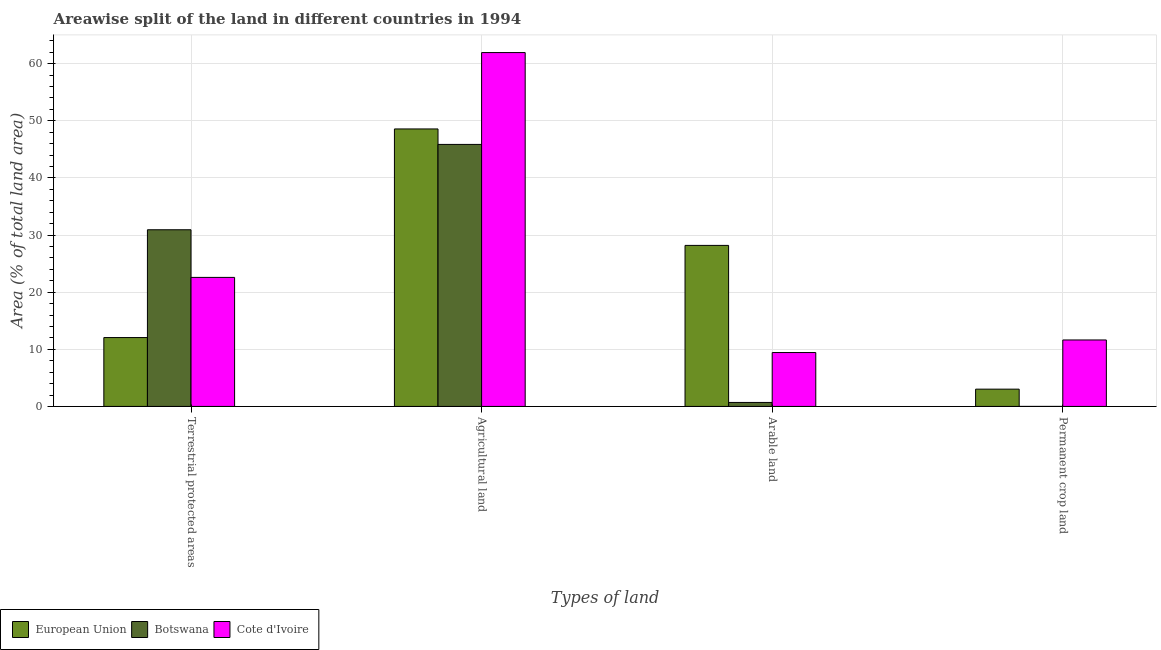How many different coloured bars are there?
Your answer should be very brief. 3. How many groups of bars are there?
Keep it short and to the point. 4. Are the number of bars on each tick of the X-axis equal?
Give a very brief answer. Yes. How many bars are there on the 1st tick from the left?
Your answer should be compact. 3. How many bars are there on the 3rd tick from the right?
Your response must be concise. 3. What is the label of the 1st group of bars from the left?
Offer a very short reply. Terrestrial protected areas. What is the percentage of area under agricultural land in Botswana?
Your response must be concise. 45.87. Across all countries, what is the maximum percentage of area under arable land?
Your answer should be compact. 28.19. Across all countries, what is the minimum percentage of land under terrestrial protection?
Your response must be concise. 12.06. In which country was the percentage of area under permanent crop land maximum?
Ensure brevity in your answer.  Cote d'Ivoire. In which country was the percentage of land under terrestrial protection minimum?
Ensure brevity in your answer.  European Union. What is the total percentage of area under arable land in the graph?
Offer a terse response. 38.32. What is the difference between the percentage of area under agricultural land in Botswana and that in Cote d'Ivoire?
Your answer should be compact. -16.08. What is the difference between the percentage of area under agricultural land in Cote d'Ivoire and the percentage of area under arable land in European Union?
Ensure brevity in your answer.  33.76. What is the average percentage of land under terrestrial protection per country?
Keep it short and to the point. 21.86. What is the difference between the percentage of area under agricultural land and percentage of area under permanent crop land in European Union?
Provide a short and direct response. 45.55. In how many countries, is the percentage of area under agricultural land greater than 32 %?
Offer a terse response. 3. What is the ratio of the percentage of area under permanent crop land in Botswana to that in European Union?
Ensure brevity in your answer.  0. Is the percentage of area under permanent crop land in Cote d'Ivoire less than that in European Union?
Keep it short and to the point. No. What is the difference between the highest and the second highest percentage of area under agricultural land?
Make the answer very short. 13.37. What is the difference between the highest and the lowest percentage of area under permanent crop land?
Offer a terse response. 11.63. In how many countries, is the percentage of land under terrestrial protection greater than the average percentage of land under terrestrial protection taken over all countries?
Ensure brevity in your answer.  2. What does the 2nd bar from the left in Permanent crop land represents?
Provide a succinct answer. Botswana. What does the 2nd bar from the right in Permanent crop land represents?
Keep it short and to the point. Botswana. Is it the case that in every country, the sum of the percentage of land under terrestrial protection and percentage of area under agricultural land is greater than the percentage of area under arable land?
Ensure brevity in your answer.  Yes. How many bars are there?
Your answer should be very brief. 12. What is the difference between two consecutive major ticks on the Y-axis?
Provide a succinct answer. 10. Where does the legend appear in the graph?
Offer a terse response. Bottom left. How many legend labels are there?
Your answer should be very brief. 3. What is the title of the graph?
Your response must be concise. Areawise split of the land in different countries in 1994. What is the label or title of the X-axis?
Your answer should be very brief. Types of land. What is the label or title of the Y-axis?
Offer a very short reply. Area (% of total land area). What is the Area (% of total land area) in European Union in Terrestrial protected areas?
Your answer should be compact. 12.06. What is the Area (% of total land area) of Botswana in Terrestrial protected areas?
Ensure brevity in your answer.  30.93. What is the Area (% of total land area) of Cote d'Ivoire in Terrestrial protected areas?
Provide a short and direct response. 22.59. What is the Area (% of total land area) of European Union in Agricultural land?
Offer a terse response. 48.58. What is the Area (% of total land area) of Botswana in Agricultural land?
Provide a succinct answer. 45.87. What is the Area (% of total land area) of Cote d'Ivoire in Agricultural land?
Make the answer very short. 61.95. What is the Area (% of total land area) of European Union in Arable land?
Ensure brevity in your answer.  28.19. What is the Area (% of total land area) in Botswana in Arable land?
Keep it short and to the point. 0.7. What is the Area (% of total land area) in Cote d'Ivoire in Arable land?
Offer a terse response. 9.43. What is the Area (% of total land area) of European Union in Permanent crop land?
Provide a succinct answer. 3.02. What is the Area (% of total land area) in Botswana in Permanent crop land?
Give a very brief answer. 0. What is the Area (% of total land area) in Cote d'Ivoire in Permanent crop land?
Offer a very short reply. 11.64. Across all Types of land, what is the maximum Area (% of total land area) of European Union?
Your answer should be compact. 48.58. Across all Types of land, what is the maximum Area (% of total land area) in Botswana?
Offer a very short reply. 45.87. Across all Types of land, what is the maximum Area (% of total land area) of Cote d'Ivoire?
Give a very brief answer. 61.95. Across all Types of land, what is the minimum Area (% of total land area) in European Union?
Your answer should be compact. 3.02. Across all Types of land, what is the minimum Area (% of total land area) in Botswana?
Keep it short and to the point. 0. Across all Types of land, what is the minimum Area (% of total land area) of Cote d'Ivoire?
Your answer should be very brief. 9.43. What is the total Area (% of total land area) in European Union in the graph?
Offer a very short reply. 91.85. What is the total Area (% of total land area) in Botswana in the graph?
Your answer should be very brief. 77.5. What is the total Area (% of total land area) of Cote d'Ivoire in the graph?
Your answer should be very brief. 105.61. What is the difference between the Area (% of total land area) in European Union in Terrestrial protected areas and that in Agricultural land?
Offer a very short reply. -36.52. What is the difference between the Area (% of total land area) of Botswana in Terrestrial protected areas and that in Agricultural land?
Provide a short and direct response. -14.94. What is the difference between the Area (% of total land area) of Cote d'Ivoire in Terrestrial protected areas and that in Agricultural land?
Your response must be concise. -39.36. What is the difference between the Area (% of total land area) in European Union in Terrestrial protected areas and that in Arable land?
Provide a succinct answer. -16.13. What is the difference between the Area (% of total land area) of Botswana in Terrestrial protected areas and that in Arable land?
Make the answer very short. 30.23. What is the difference between the Area (% of total land area) in Cote d'Ivoire in Terrestrial protected areas and that in Arable land?
Offer a terse response. 13.16. What is the difference between the Area (% of total land area) of European Union in Terrestrial protected areas and that in Permanent crop land?
Give a very brief answer. 9.03. What is the difference between the Area (% of total land area) in Botswana in Terrestrial protected areas and that in Permanent crop land?
Offer a terse response. 30.93. What is the difference between the Area (% of total land area) of Cote d'Ivoire in Terrestrial protected areas and that in Permanent crop land?
Provide a short and direct response. 10.95. What is the difference between the Area (% of total land area) in European Union in Agricultural land and that in Arable land?
Offer a terse response. 20.39. What is the difference between the Area (% of total land area) of Botswana in Agricultural land and that in Arable land?
Ensure brevity in your answer.  45.17. What is the difference between the Area (% of total land area) in Cote d'Ivoire in Agricultural land and that in Arable land?
Your answer should be compact. 52.52. What is the difference between the Area (% of total land area) of European Union in Agricultural land and that in Permanent crop land?
Your answer should be compact. 45.55. What is the difference between the Area (% of total land area) in Botswana in Agricultural land and that in Permanent crop land?
Keep it short and to the point. 45.87. What is the difference between the Area (% of total land area) of Cote d'Ivoire in Agricultural land and that in Permanent crop land?
Give a very brief answer. 50.31. What is the difference between the Area (% of total land area) of European Union in Arable land and that in Permanent crop land?
Ensure brevity in your answer.  25.17. What is the difference between the Area (% of total land area) in Botswana in Arable land and that in Permanent crop land?
Your answer should be compact. 0.7. What is the difference between the Area (% of total land area) in Cote d'Ivoire in Arable land and that in Permanent crop land?
Offer a terse response. -2.2. What is the difference between the Area (% of total land area) of European Union in Terrestrial protected areas and the Area (% of total land area) of Botswana in Agricultural land?
Make the answer very short. -33.81. What is the difference between the Area (% of total land area) in European Union in Terrestrial protected areas and the Area (% of total land area) in Cote d'Ivoire in Agricultural land?
Provide a succinct answer. -49.89. What is the difference between the Area (% of total land area) in Botswana in Terrestrial protected areas and the Area (% of total land area) in Cote d'Ivoire in Agricultural land?
Keep it short and to the point. -31.02. What is the difference between the Area (% of total land area) in European Union in Terrestrial protected areas and the Area (% of total land area) in Botswana in Arable land?
Provide a succinct answer. 11.36. What is the difference between the Area (% of total land area) of European Union in Terrestrial protected areas and the Area (% of total land area) of Cote d'Ivoire in Arable land?
Offer a terse response. 2.62. What is the difference between the Area (% of total land area) of Botswana in Terrestrial protected areas and the Area (% of total land area) of Cote d'Ivoire in Arable land?
Your answer should be very brief. 21.5. What is the difference between the Area (% of total land area) of European Union in Terrestrial protected areas and the Area (% of total land area) of Botswana in Permanent crop land?
Provide a short and direct response. 12.06. What is the difference between the Area (% of total land area) in European Union in Terrestrial protected areas and the Area (% of total land area) in Cote d'Ivoire in Permanent crop land?
Offer a terse response. 0.42. What is the difference between the Area (% of total land area) of Botswana in Terrestrial protected areas and the Area (% of total land area) of Cote d'Ivoire in Permanent crop land?
Offer a very short reply. 19.3. What is the difference between the Area (% of total land area) in European Union in Agricultural land and the Area (% of total land area) in Botswana in Arable land?
Offer a very short reply. 47.88. What is the difference between the Area (% of total land area) in European Union in Agricultural land and the Area (% of total land area) in Cote d'Ivoire in Arable land?
Keep it short and to the point. 39.14. What is the difference between the Area (% of total land area) of Botswana in Agricultural land and the Area (% of total land area) of Cote d'Ivoire in Arable land?
Keep it short and to the point. 36.44. What is the difference between the Area (% of total land area) of European Union in Agricultural land and the Area (% of total land area) of Botswana in Permanent crop land?
Give a very brief answer. 48.58. What is the difference between the Area (% of total land area) of European Union in Agricultural land and the Area (% of total land area) of Cote d'Ivoire in Permanent crop land?
Offer a terse response. 36.94. What is the difference between the Area (% of total land area) in Botswana in Agricultural land and the Area (% of total land area) in Cote d'Ivoire in Permanent crop land?
Offer a very short reply. 34.23. What is the difference between the Area (% of total land area) of European Union in Arable land and the Area (% of total land area) of Botswana in Permanent crop land?
Keep it short and to the point. 28.19. What is the difference between the Area (% of total land area) in European Union in Arable land and the Area (% of total land area) in Cote d'Ivoire in Permanent crop land?
Ensure brevity in your answer.  16.56. What is the difference between the Area (% of total land area) of Botswana in Arable land and the Area (% of total land area) of Cote d'Ivoire in Permanent crop land?
Your response must be concise. -10.94. What is the average Area (% of total land area) of European Union per Types of land?
Your answer should be compact. 22.96. What is the average Area (% of total land area) of Botswana per Types of land?
Offer a terse response. 19.37. What is the average Area (% of total land area) of Cote d'Ivoire per Types of land?
Provide a succinct answer. 26.4. What is the difference between the Area (% of total land area) of European Union and Area (% of total land area) of Botswana in Terrestrial protected areas?
Offer a very short reply. -18.87. What is the difference between the Area (% of total land area) of European Union and Area (% of total land area) of Cote d'Ivoire in Terrestrial protected areas?
Your response must be concise. -10.53. What is the difference between the Area (% of total land area) of Botswana and Area (% of total land area) of Cote d'Ivoire in Terrestrial protected areas?
Make the answer very short. 8.34. What is the difference between the Area (% of total land area) in European Union and Area (% of total land area) in Botswana in Agricultural land?
Offer a very short reply. 2.71. What is the difference between the Area (% of total land area) in European Union and Area (% of total land area) in Cote d'Ivoire in Agricultural land?
Offer a terse response. -13.37. What is the difference between the Area (% of total land area) of Botswana and Area (% of total land area) of Cote d'Ivoire in Agricultural land?
Provide a short and direct response. -16.08. What is the difference between the Area (% of total land area) in European Union and Area (% of total land area) in Botswana in Arable land?
Make the answer very short. 27.49. What is the difference between the Area (% of total land area) of European Union and Area (% of total land area) of Cote d'Ivoire in Arable land?
Keep it short and to the point. 18.76. What is the difference between the Area (% of total land area) of Botswana and Area (% of total land area) of Cote d'Ivoire in Arable land?
Offer a terse response. -8.74. What is the difference between the Area (% of total land area) of European Union and Area (% of total land area) of Botswana in Permanent crop land?
Keep it short and to the point. 3.02. What is the difference between the Area (% of total land area) in European Union and Area (% of total land area) in Cote d'Ivoire in Permanent crop land?
Offer a terse response. -8.61. What is the difference between the Area (% of total land area) in Botswana and Area (% of total land area) in Cote d'Ivoire in Permanent crop land?
Your answer should be compact. -11.63. What is the ratio of the Area (% of total land area) in European Union in Terrestrial protected areas to that in Agricultural land?
Your response must be concise. 0.25. What is the ratio of the Area (% of total land area) in Botswana in Terrestrial protected areas to that in Agricultural land?
Give a very brief answer. 0.67. What is the ratio of the Area (% of total land area) of Cote d'Ivoire in Terrestrial protected areas to that in Agricultural land?
Ensure brevity in your answer.  0.36. What is the ratio of the Area (% of total land area) of European Union in Terrestrial protected areas to that in Arable land?
Make the answer very short. 0.43. What is the ratio of the Area (% of total land area) of Botswana in Terrestrial protected areas to that in Arable land?
Your answer should be very brief. 44.38. What is the ratio of the Area (% of total land area) in Cote d'Ivoire in Terrestrial protected areas to that in Arable land?
Keep it short and to the point. 2.39. What is the ratio of the Area (% of total land area) in European Union in Terrestrial protected areas to that in Permanent crop land?
Provide a short and direct response. 3.99. What is the ratio of the Area (% of total land area) of Botswana in Terrestrial protected areas to that in Permanent crop land?
Provide a succinct answer. 1.75e+04. What is the ratio of the Area (% of total land area) in Cote d'Ivoire in Terrestrial protected areas to that in Permanent crop land?
Provide a short and direct response. 1.94. What is the ratio of the Area (% of total land area) in European Union in Agricultural land to that in Arable land?
Your answer should be very brief. 1.72. What is the ratio of the Area (% of total land area) in Botswana in Agricultural land to that in Arable land?
Offer a very short reply. 65.81. What is the ratio of the Area (% of total land area) in Cote d'Ivoire in Agricultural land to that in Arable land?
Give a very brief answer. 6.57. What is the ratio of the Area (% of total land area) in European Union in Agricultural land to that in Permanent crop land?
Offer a very short reply. 16.06. What is the ratio of the Area (% of total land area) of Botswana in Agricultural land to that in Permanent crop land?
Offer a terse response. 2.60e+04. What is the ratio of the Area (% of total land area) of Cote d'Ivoire in Agricultural land to that in Permanent crop land?
Offer a terse response. 5.32. What is the ratio of the Area (% of total land area) of European Union in Arable land to that in Permanent crop land?
Your response must be concise. 9.32. What is the ratio of the Area (% of total land area) of Botswana in Arable land to that in Permanent crop land?
Your response must be concise. 395. What is the ratio of the Area (% of total land area) of Cote d'Ivoire in Arable land to that in Permanent crop land?
Your response must be concise. 0.81. What is the difference between the highest and the second highest Area (% of total land area) in European Union?
Your answer should be very brief. 20.39. What is the difference between the highest and the second highest Area (% of total land area) in Botswana?
Give a very brief answer. 14.94. What is the difference between the highest and the second highest Area (% of total land area) in Cote d'Ivoire?
Ensure brevity in your answer.  39.36. What is the difference between the highest and the lowest Area (% of total land area) in European Union?
Your answer should be very brief. 45.55. What is the difference between the highest and the lowest Area (% of total land area) of Botswana?
Keep it short and to the point. 45.87. What is the difference between the highest and the lowest Area (% of total land area) of Cote d'Ivoire?
Ensure brevity in your answer.  52.52. 